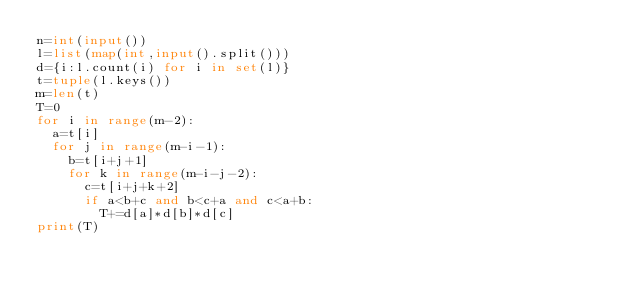<code> <loc_0><loc_0><loc_500><loc_500><_Python_>n=int(input())
l=list(map(int,input().split()))
d={i:l.count(i) for i in set(l)}
t=tuple(l.keys())
m=len(t)
T=0
for i in range(m-2):
  a=t[i]
  for j in range(m-i-1):
    b=t[i+j+1]
    for k in range(m-i-j-2):
      c=t[i+j+k+2]
      if a<b+c and b<c+a and c<a+b:
        T+=d[a]*d[b]*d[c]
print(T)</code> 